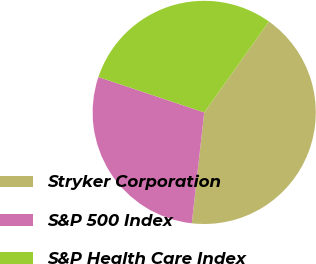Convert chart. <chart><loc_0><loc_0><loc_500><loc_500><pie_chart><fcel>Stryker Corporation<fcel>S&P 500 Index<fcel>S&P Health Care Index<nl><fcel>41.93%<fcel>28.36%<fcel>29.71%<nl></chart> 